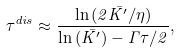<formula> <loc_0><loc_0><loc_500><loc_500>\tau _ { } ^ { d i s } \approx \frac { \ln { ( 2 \bar { K ^ { \prime } } / \eta ) } } { \ln { ( \bar { K ^ { \prime } } ) } - \Gamma \tau / 2 } ,</formula> 